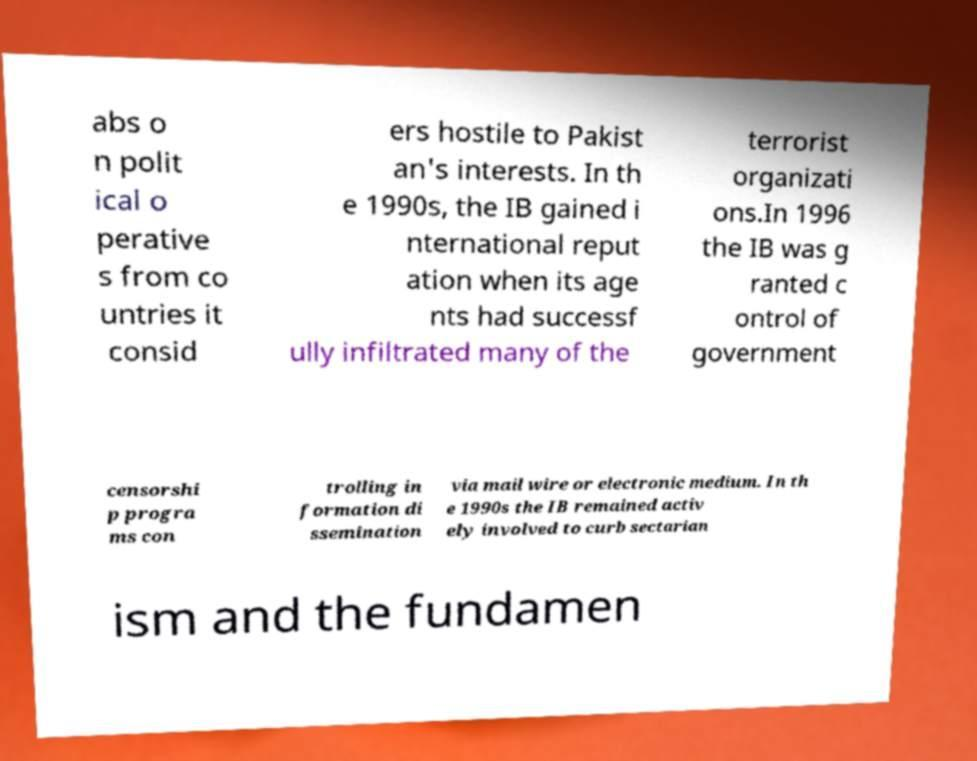Can you accurately transcribe the text from the provided image for me? abs o n polit ical o perative s from co untries it consid ers hostile to Pakist an's interests. In th e 1990s, the IB gained i nternational reput ation when its age nts had successf ully infiltrated many of the terrorist organizati ons.In 1996 the IB was g ranted c ontrol of government censorshi p progra ms con trolling in formation di ssemination via mail wire or electronic medium. In th e 1990s the IB remained activ ely involved to curb sectarian ism and the fundamen 